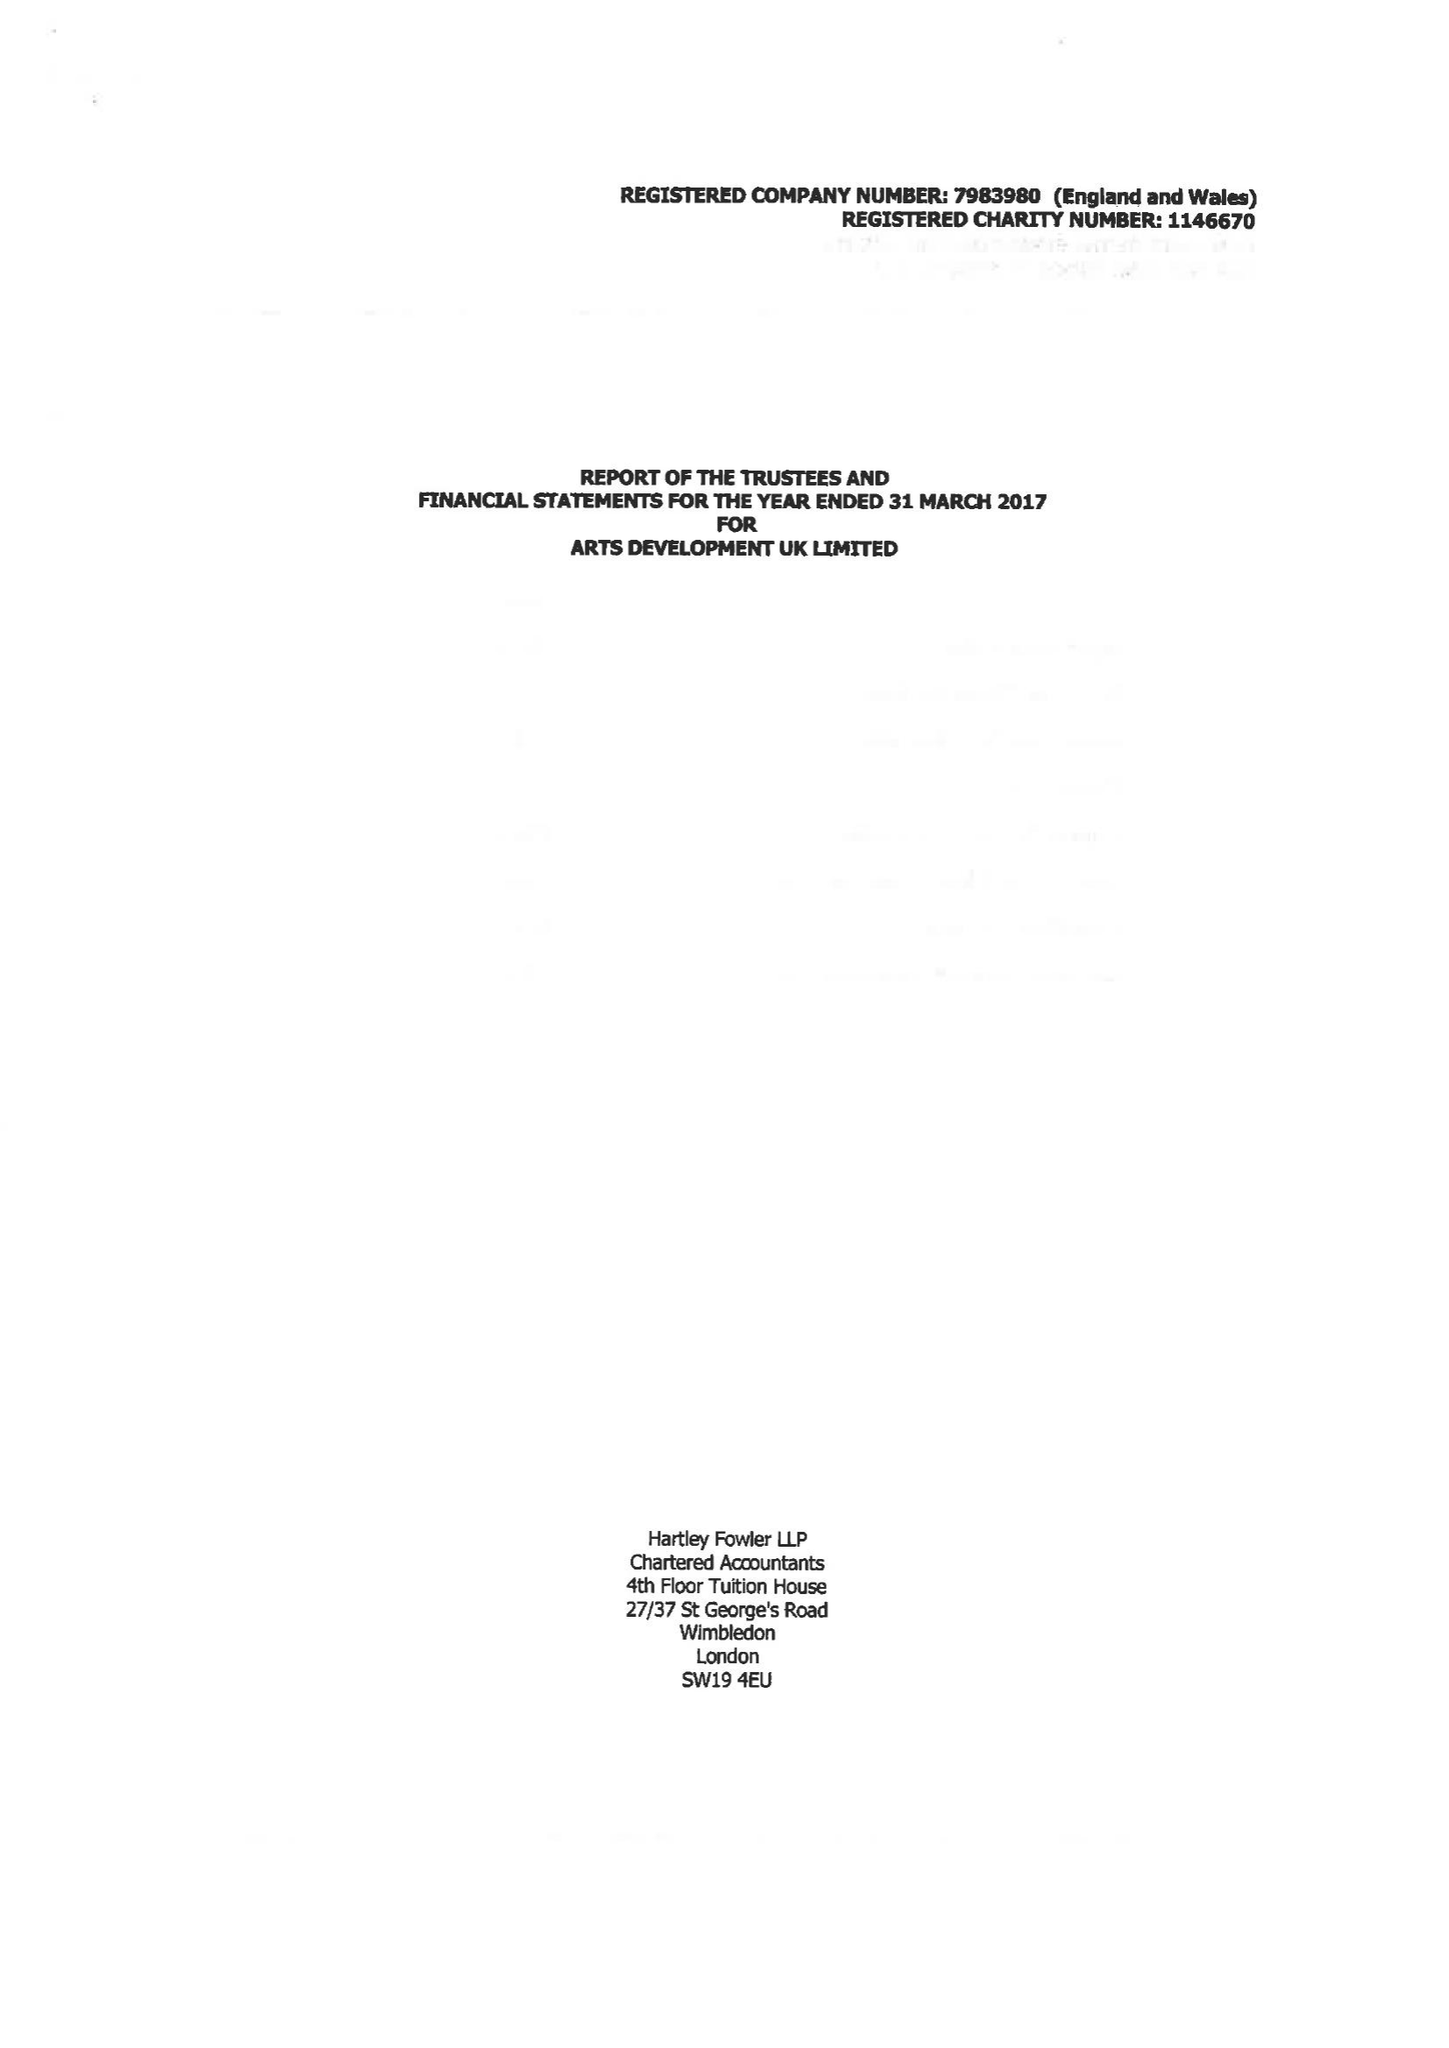What is the value for the charity_number?
Answer the question using a single word or phrase. 1146670 